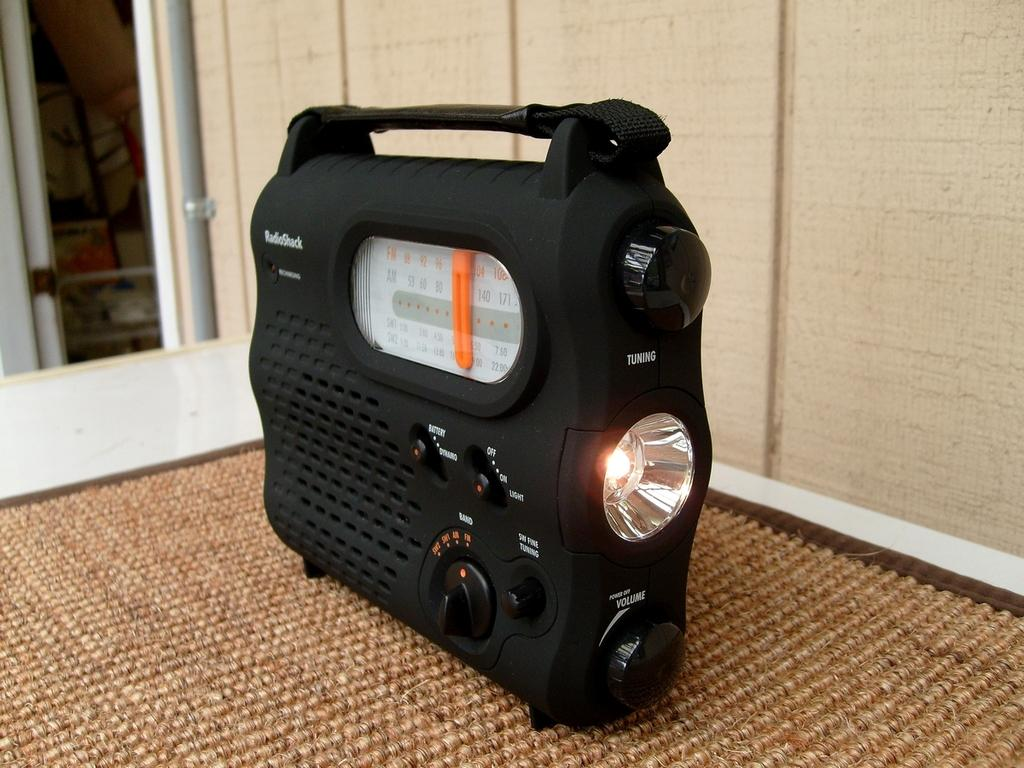What electronic device is the main subject of the image? There is a radio in the image. What features does the radio have? The radio has tuners, buttons, a speaker, and a light. Where is the radio placed in the image? The radio is on a mat, which is on a table. What can be seen in the background of the image? There is a pipe and a wall in the background of the image. Can you tell me how many hens are sitting on the radio in the image? There are no hens present in the image; it features a radio on a mat on a table with a pipe and a wall in the background. 